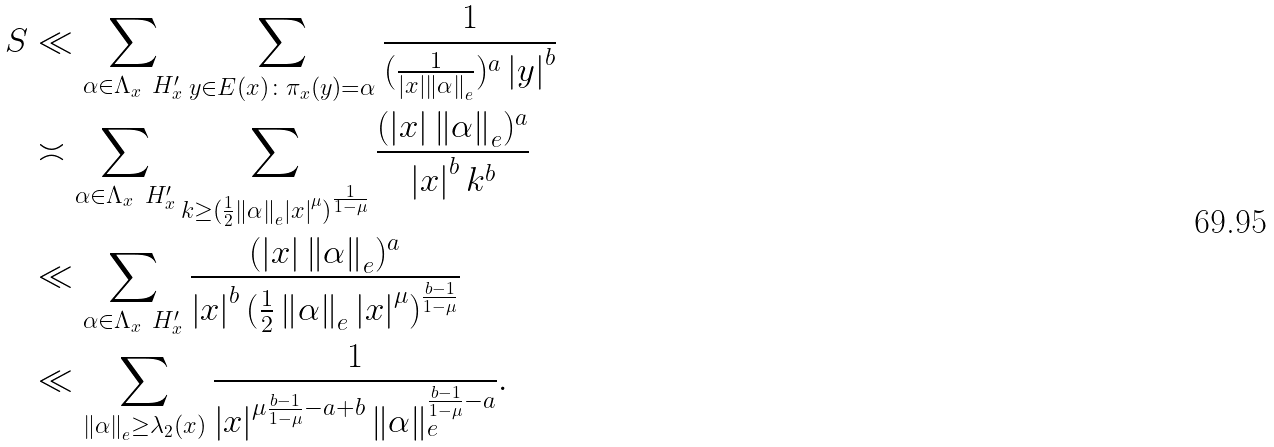Convert formula to latex. <formula><loc_0><loc_0><loc_500><loc_500>S & \ll \sum _ { \alpha \in \Lambda _ { x } \ H _ { x } ^ { \prime } } \sum _ { y \in E ( x ) \colon \pi _ { x } ( y ) = \alpha } \frac { 1 } { ( \frac { 1 } { \left | x \right | \left \| \alpha \right \| _ { e } } ) ^ { a } \left | y \right | ^ { b } } \\ & \asymp \sum _ { \alpha \in \Lambda _ { x } \ H _ { x } ^ { \prime } } \sum _ { k \geq ( \frac { 1 } { 2 } \left \| \alpha \right \| _ { e } \left | x \right | ^ { \mu } ) ^ { \frac { 1 } { 1 - \mu } } } \frac { ( \left | x \right | \left \| \alpha \right \| _ { e } ) ^ { a } } { \left | x \right | ^ { b } k ^ { b } } \\ & \ll \sum _ { \alpha \in \Lambda _ { x } \ H _ { x } ^ { \prime } } \frac { ( \left | x \right | \left \| \alpha \right \| _ { e } ) ^ { a } } { \left | x \right | ^ { b } ( \frac { 1 } { 2 } \left \| \alpha \right \| _ { e } \left | x \right | ^ { \mu } ) ^ { \frac { b - 1 } { 1 - \mu } } } \\ & \ll \sum _ { \left \| \alpha \right \| _ { e } \geq \lambda _ { 2 } ( x ) } \frac { 1 } { \left | x \right | ^ { \mu \frac { b - 1 } { 1 - \mu } - a + b } \left \| \alpha \right \| _ { e } ^ { \frac { b - 1 } { 1 - \mu } - a } } .</formula> 